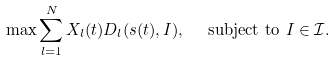<formula> <loc_0><loc_0><loc_500><loc_500>& \max \sum _ { l = 1 } ^ { N } X _ { l } ( t ) D _ { l } ( s ( t ) , I ) , \ \quad \text {subject to } I \in \mathcal { I } .</formula> 